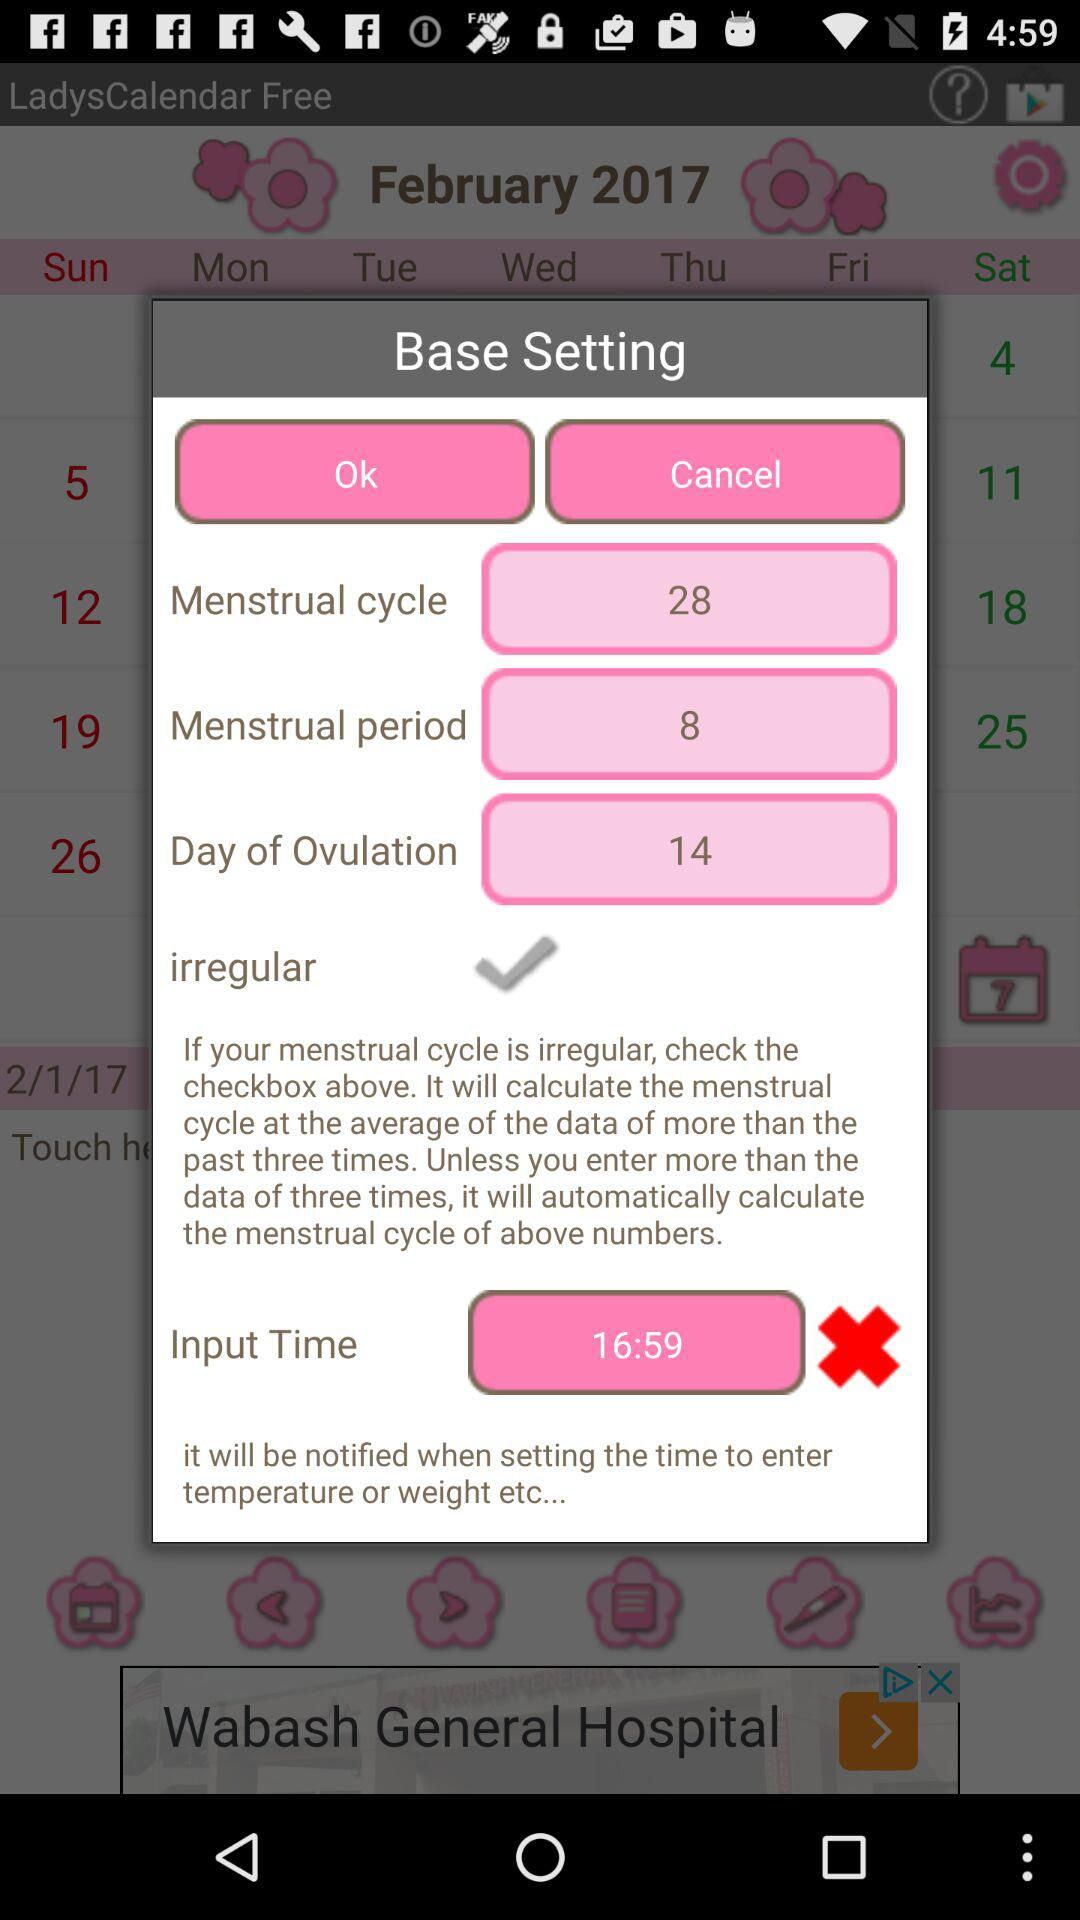What is the input time? The input time is 16:59. 